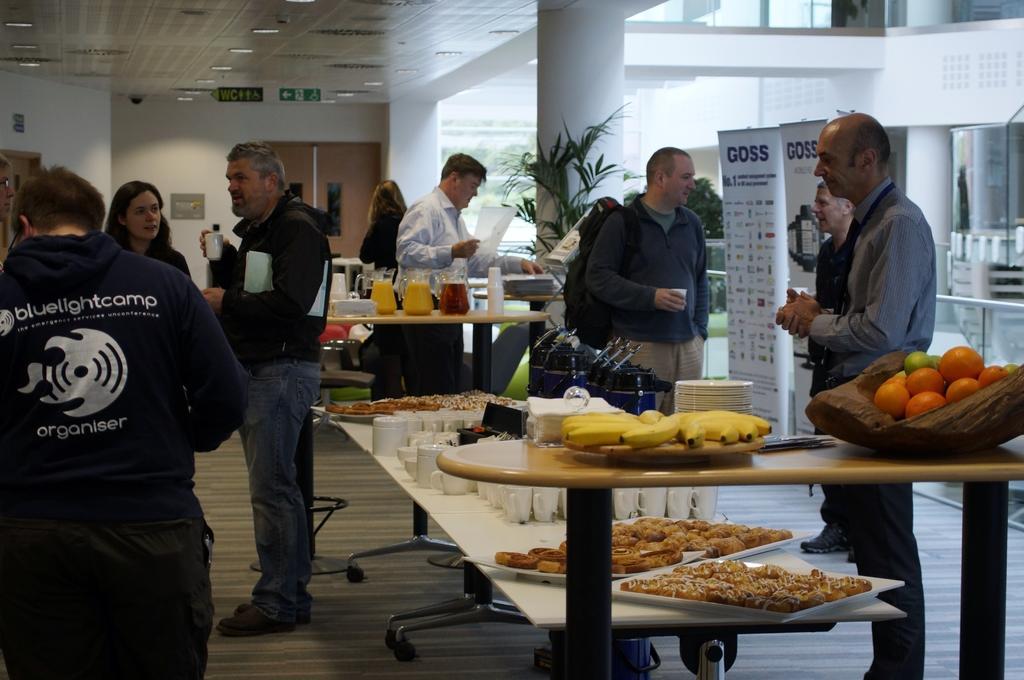Can you describe this image briefly? On the left side, there is group of persons standing, near a table, on which, there are white color cups and food items on the trays. On the right side, there are fruits in a basket, bananas on the wooden plate and papers on the table. In the background, there are persons standing, there are bottles and jars on the table, there is a pillar, near pot plant, there is white wall, light attached to the roof and there are other objects. 